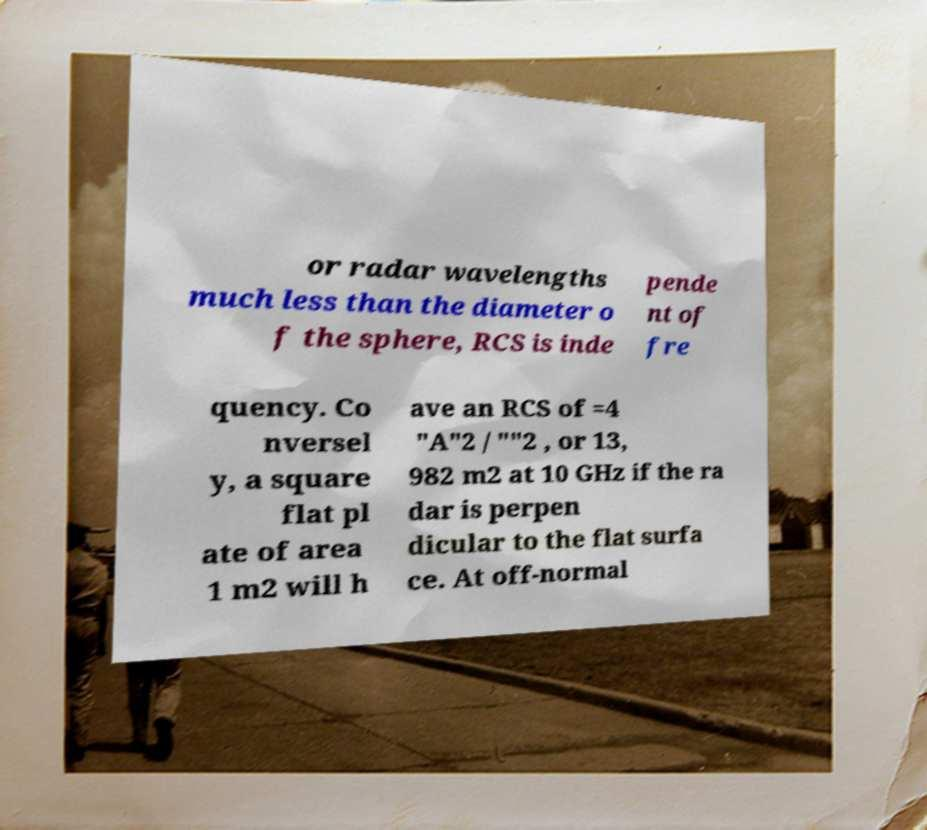Please read and relay the text visible in this image. What does it say? or radar wavelengths much less than the diameter o f the sphere, RCS is inde pende nt of fre quency. Co nversel y, a square flat pl ate of area 1 m2 will h ave an RCS of =4 "A"2 / ""2 , or 13, 982 m2 at 10 GHz if the ra dar is perpen dicular to the flat surfa ce. At off-normal 